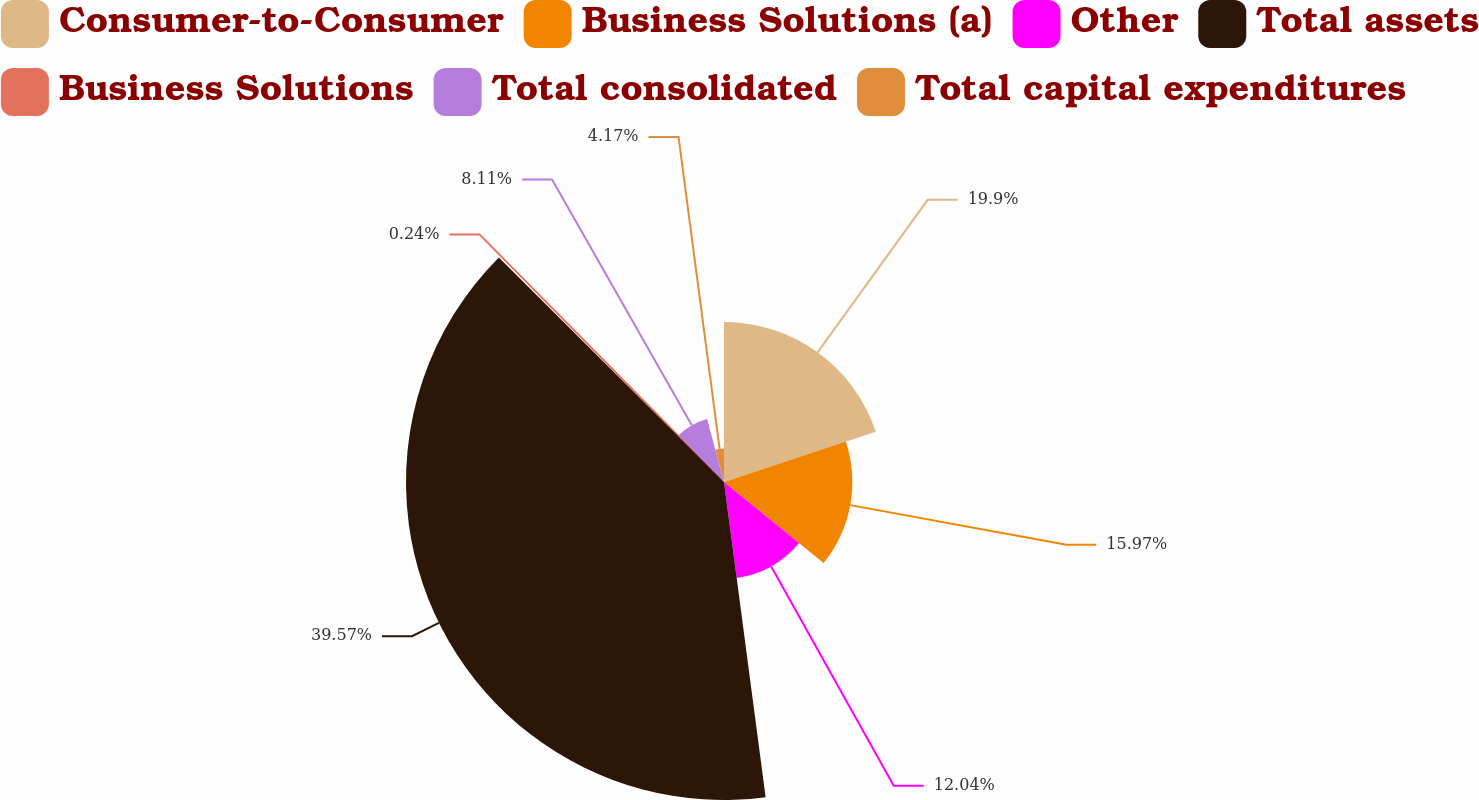Convert chart. <chart><loc_0><loc_0><loc_500><loc_500><pie_chart><fcel>Consumer-to-Consumer<fcel>Business Solutions (a)<fcel>Other<fcel>Total assets<fcel>Business Solutions<fcel>Total consolidated<fcel>Total capital expenditures<nl><fcel>19.9%<fcel>15.97%<fcel>12.04%<fcel>39.57%<fcel>0.24%<fcel>8.11%<fcel>4.17%<nl></chart> 